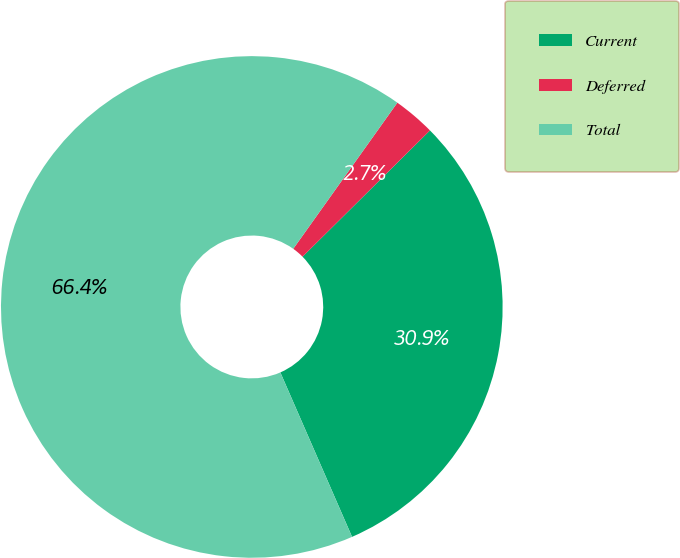Convert chart. <chart><loc_0><loc_0><loc_500><loc_500><pie_chart><fcel>Current<fcel>Deferred<fcel>Total<nl><fcel>30.88%<fcel>2.72%<fcel>66.39%<nl></chart> 